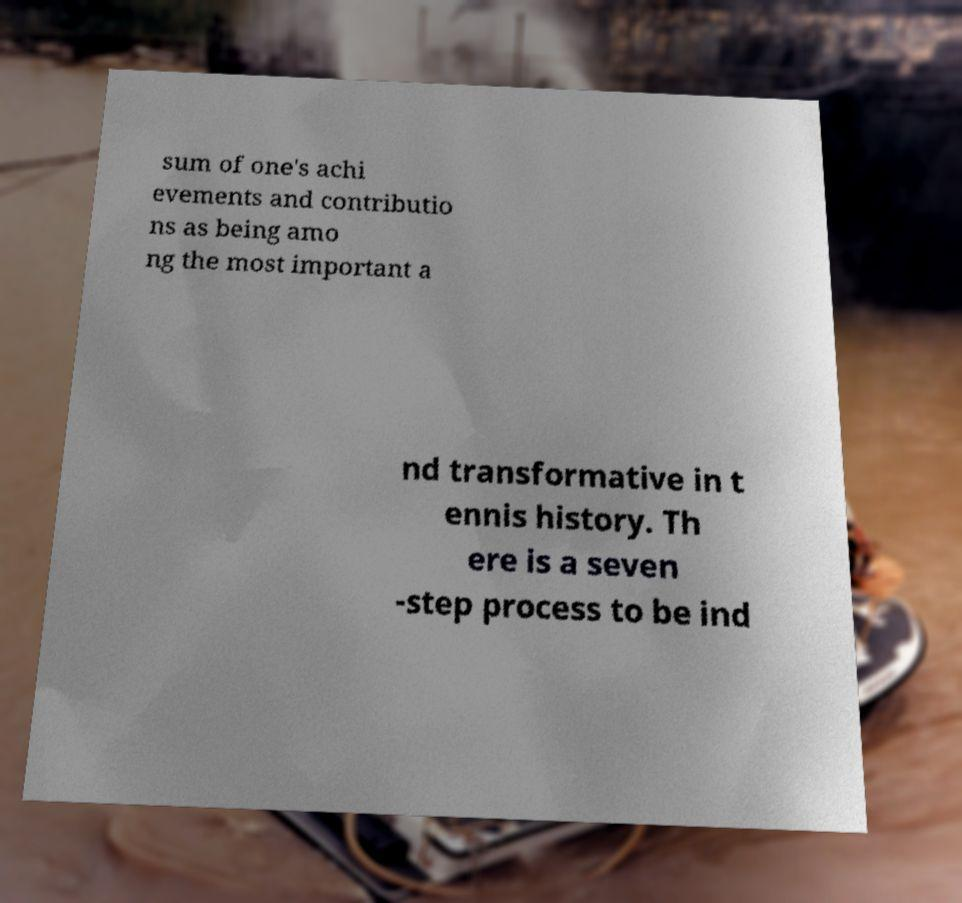Please identify and transcribe the text found in this image. sum of one's achi evements and contributio ns as being amo ng the most important a nd transformative in t ennis history. Th ere is a seven -step process to be ind 